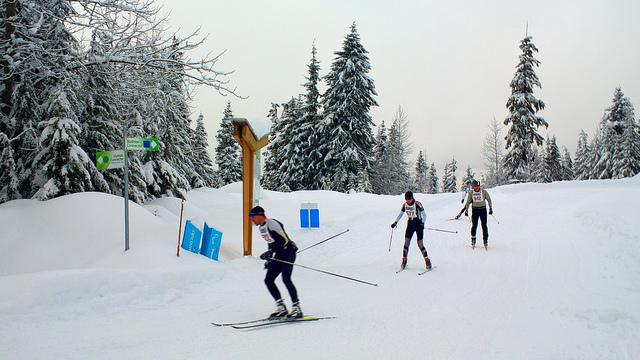How many skiers are in this photo?
Give a very brief answer. 3. Are the snow drifts high?
Write a very short answer. Yes. What color is the sky?
Keep it brief. Gray. What is covering the trees?
Give a very brief answer. Snow. Is there snow?
Short answer required. Yes. Is the snow deep?
Quick response, please. Yes. How many people?
Concise answer only. 3. 